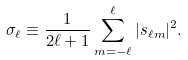Convert formula to latex. <formula><loc_0><loc_0><loc_500><loc_500>\sigma _ { \ell } \equiv \frac { 1 } { 2 \ell + 1 } \sum _ { m = - \ell } ^ { \ell } | s _ { \ell m } | ^ { 2 } .</formula> 